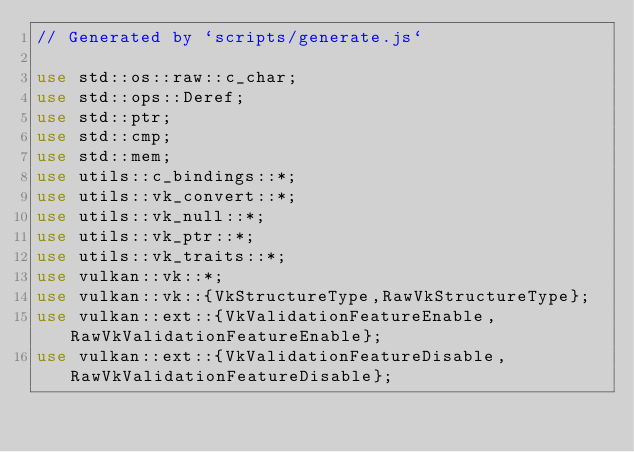<code> <loc_0><loc_0><loc_500><loc_500><_Rust_>// Generated by `scripts/generate.js`

use std::os::raw::c_char;
use std::ops::Deref;
use std::ptr;
use std::cmp;
use std::mem;
use utils::c_bindings::*;
use utils::vk_convert::*;
use utils::vk_null::*;
use utils::vk_ptr::*;
use utils::vk_traits::*;
use vulkan::vk::*;
use vulkan::vk::{VkStructureType,RawVkStructureType};
use vulkan::ext::{VkValidationFeatureEnable,RawVkValidationFeatureEnable};
use vulkan::ext::{VkValidationFeatureDisable,RawVkValidationFeatureDisable};
</code> 